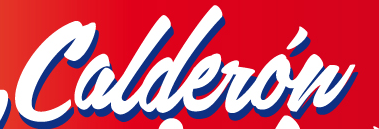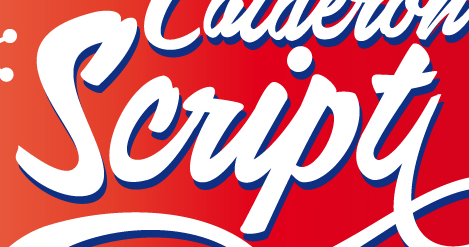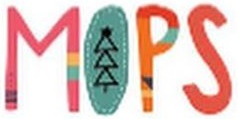Transcribe the words shown in these images in order, separated by a semicolon. Calderów; Script; MOPS 